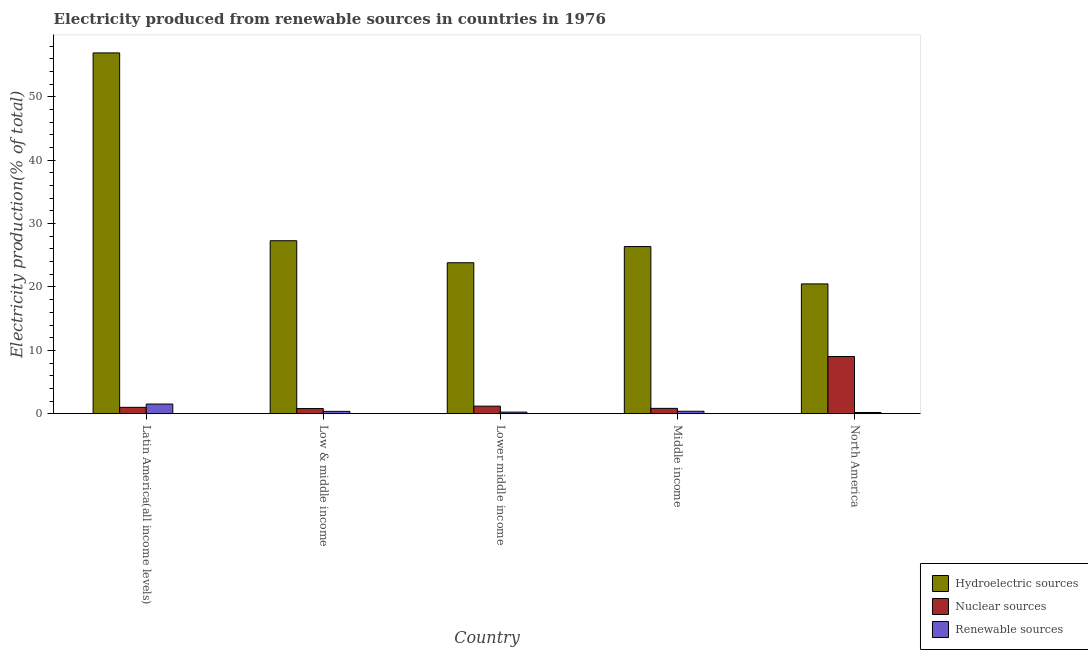How many groups of bars are there?
Keep it short and to the point. 5. Are the number of bars per tick equal to the number of legend labels?
Offer a terse response. Yes. How many bars are there on the 5th tick from the left?
Offer a very short reply. 3. How many bars are there on the 3rd tick from the right?
Your answer should be compact. 3. What is the percentage of electricity produced by hydroelectric sources in North America?
Offer a terse response. 20.48. Across all countries, what is the maximum percentage of electricity produced by hydroelectric sources?
Your answer should be compact. 56.93. Across all countries, what is the minimum percentage of electricity produced by nuclear sources?
Your answer should be compact. 0.81. In which country was the percentage of electricity produced by hydroelectric sources maximum?
Make the answer very short. Latin America(all income levels). In which country was the percentage of electricity produced by renewable sources minimum?
Make the answer very short. North America. What is the total percentage of electricity produced by hydroelectric sources in the graph?
Provide a short and direct response. 154.91. What is the difference between the percentage of electricity produced by renewable sources in Low & middle income and that in Middle income?
Your answer should be very brief. -0.01. What is the difference between the percentage of electricity produced by nuclear sources in Middle income and the percentage of electricity produced by renewable sources in North America?
Ensure brevity in your answer.  0.65. What is the average percentage of electricity produced by hydroelectric sources per country?
Your answer should be very brief. 30.98. What is the difference between the percentage of electricity produced by renewable sources and percentage of electricity produced by hydroelectric sources in Low & middle income?
Your answer should be very brief. -26.92. In how many countries, is the percentage of electricity produced by nuclear sources greater than 44 %?
Make the answer very short. 0. What is the ratio of the percentage of electricity produced by nuclear sources in Low & middle income to that in Lower middle income?
Your answer should be very brief. 0.68. What is the difference between the highest and the second highest percentage of electricity produced by hydroelectric sources?
Make the answer very short. 29.63. What is the difference between the highest and the lowest percentage of electricity produced by renewable sources?
Provide a short and direct response. 1.33. Is the sum of the percentage of electricity produced by nuclear sources in Latin America(all income levels) and Middle income greater than the maximum percentage of electricity produced by renewable sources across all countries?
Provide a succinct answer. Yes. What does the 2nd bar from the left in Low & middle income represents?
Your answer should be compact. Nuclear sources. What does the 2nd bar from the right in Middle income represents?
Give a very brief answer. Nuclear sources. Are all the bars in the graph horizontal?
Your answer should be very brief. No. Does the graph contain any zero values?
Make the answer very short. No. How are the legend labels stacked?
Provide a succinct answer. Vertical. What is the title of the graph?
Offer a very short reply. Electricity produced from renewable sources in countries in 1976. What is the Electricity production(% of total) in Hydroelectric sources in Latin America(all income levels)?
Provide a succinct answer. 56.93. What is the Electricity production(% of total) in Nuclear sources in Latin America(all income levels)?
Ensure brevity in your answer.  1.01. What is the Electricity production(% of total) of Renewable sources in Latin America(all income levels)?
Keep it short and to the point. 1.53. What is the Electricity production(% of total) in Hydroelectric sources in Low & middle income?
Keep it short and to the point. 27.3. What is the Electricity production(% of total) in Nuclear sources in Low & middle income?
Your response must be concise. 0.81. What is the Electricity production(% of total) of Renewable sources in Low & middle income?
Provide a succinct answer. 0.38. What is the Electricity production(% of total) in Hydroelectric sources in Lower middle income?
Your response must be concise. 23.83. What is the Electricity production(% of total) in Nuclear sources in Lower middle income?
Your answer should be compact. 1.2. What is the Electricity production(% of total) of Renewable sources in Lower middle income?
Your answer should be very brief. 0.25. What is the Electricity production(% of total) in Hydroelectric sources in Middle income?
Ensure brevity in your answer.  26.38. What is the Electricity production(% of total) of Nuclear sources in Middle income?
Offer a very short reply. 0.85. What is the Electricity production(% of total) of Renewable sources in Middle income?
Make the answer very short. 0.39. What is the Electricity production(% of total) of Hydroelectric sources in North America?
Keep it short and to the point. 20.48. What is the Electricity production(% of total) in Nuclear sources in North America?
Provide a short and direct response. 9.03. What is the Electricity production(% of total) of Renewable sources in North America?
Your answer should be compact. 0.2. Across all countries, what is the maximum Electricity production(% of total) of Hydroelectric sources?
Provide a succinct answer. 56.93. Across all countries, what is the maximum Electricity production(% of total) of Nuclear sources?
Offer a very short reply. 9.03. Across all countries, what is the maximum Electricity production(% of total) in Renewable sources?
Your answer should be compact. 1.53. Across all countries, what is the minimum Electricity production(% of total) of Hydroelectric sources?
Your answer should be compact. 20.48. Across all countries, what is the minimum Electricity production(% of total) of Nuclear sources?
Offer a terse response. 0.81. Across all countries, what is the minimum Electricity production(% of total) of Renewable sources?
Provide a short and direct response. 0.2. What is the total Electricity production(% of total) in Hydroelectric sources in the graph?
Offer a terse response. 154.91. What is the total Electricity production(% of total) in Nuclear sources in the graph?
Your answer should be compact. 12.9. What is the total Electricity production(% of total) in Renewable sources in the graph?
Offer a terse response. 2.75. What is the difference between the Electricity production(% of total) of Hydroelectric sources in Latin America(all income levels) and that in Low & middle income?
Provide a succinct answer. 29.63. What is the difference between the Electricity production(% of total) in Nuclear sources in Latin America(all income levels) and that in Low & middle income?
Your response must be concise. 0.2. What is the difference between the Electricity production(% of total) of Renewable sources in Latin America(all income levels) and that in Low & middle income?
Give a very brief answer. 1.16. What is the difference between the Electricity production(% of total) of Hydroelectric sources in Latin America(all income levels) and that in Lower middle income?
Provide a succinct answer. 33.1. What is the difference between the Electricity production(% of total) in Nuclear sources in Latin America(all income levels) and that in Lower middle income?
Offer a terse response. -0.19. What is the difference between the Electricity production(% of total) of Renewable sources in Latin America(all income levels) and that in Lower middle income?
Keep it short and to the point. 1.28. What is the difference between the Electricity production(% of total) in Hydroelectric sources in Latin America(all income levels) and that in Middle income?
Make the answer very short. 30.55. What is the difference between the Electricity production(% of total) of Nuclear sources in Latin America(all income levels) and that in Middle income?
Make the answer very short. 0.16. What is the difference between the Electricity production(% of total) of Renewable sources in Latin America(all income levels) and that in Middle income?
Provide a succinct answer. 1.14. What is the difference between the Electricity production(% of total) in Hydroelectric sources in Latin America(all income levels) and that in North America?
Provide a short and direct response. 36.44. What is the difference between the Electricity production(% of total) in Nuclear sources in Latin America(all income levels) and that in North America?
Your answer should be very brief. -8.02. What is the difference between the Electricity production(% of total) in Renewable sources in Latin America(all income levels) and that in North America?
Provide a short and direct response. 1.33. What is the difference between the Electricity production(% of total) of Hydroelectric sources in Low & middle income and that in Lower middle income?
Ensure brevity in your answer.  3.47. What is the difference between the Electricity production(% of total) of Nuclear sources in Low & middle income and that in Lower middle income?
Make the answer very short. -0.39. What is the difference between the Electricity production(% of total) in Renewable sources in Low & middle income and that in Lower middle income?
Provide a short and direct response. 0.12. What is the difference between the Electricity production(% of total) in Hydroelectric sources in Low & middle income and that in Middle income?
Give a very brief answer. 0.92. What is the difference between the Electricity production(% of total) in Nuclear sources in Low & middle income and that in Middle income?
Provide a succinct answer. -0.03. What is the difference between the Electricity production(% of total) in Renewable sources in Low & middle income and that in Middle income?
Your response must be concise. -0.01. What is the difference between the Electricity production(% of total) of Hydroelectric sources in Low & middle income and that in North America?
Provide a succinct answer. 6.81. What is the difference between the Electricity production(% of total) in Nuclear sources in Low & middle income and that in North America?
Keep it short and to the point. -8.21. What is the difference between the Electricity production(% of total) in Renewable sources in Low & middle income and that in North America?
Make the answer very short. 0.18. What is the difference between the Electricity production(% of total) of Hydroelectric sources in Lower middle income and that in Middle income?
Your answer should be compact. -2.55. What is the difference between the Electricity production(% of total) in Nuclear sources in Lower middle income and that in Middle income?
Offer a terse response. 0.35. What is the difference between the Electricity production(% of total) of Renewable sources in Lower middle income and that in Middle income?
Make the answer very short. -0.14. What is the difference between the Electricity production(% of total) in Hydroelectric sources in Lower middle income and that in North America?
Your answer should be compact. 3.34. What is the difference between the Electricity production(% of total) in Nuclear sources in Lower middle income and that in North America?
Ensure brevity in your answer.  -7.83. What is the difference between the Electricity production(% of total) in Renewable sources in Lower middle income and that in North America?
Keep it short and to the point. 0.06. What is the difference between the Electricity production(% of total) in Hydroelectric sources in Middle income and that in North America?
Your response must be concise. 5.89. What is the difference between the Electricity production(% of total) in Nuclear sources in Middle income and that in North America?
Provide a succinct answer. -8.18. What is the difference between the Electricity production(% of total) of Renewable sources in Middle income and that in North America?
Your answer should be very brief. 0.19. What is the difference between the Electricity production(% of total) in Hydroelectric sources in Latin America(all income levels) and the Electricity production(% of total) in Nuclear sources in Low & middle income?
Your response must be concise. 56.11. What is the difference between the Electricity production(% of total) in Hydroelectric sources in Latin America(all income levels) and the Electricity production(% of total) in Renewable sources in Low & middle income?
Offer a very short reply. 56.55. What is the difference between the Electricity production(% of total) in Nuclear sources in Latin America(all income levels) and the Electricity production(% of total) in Renewable sources in Low & middle income?
Provide a succinct answer. 0.64. What is the difference between the Electricity production(% of total) in Hydroelectric sources in Latin America(all income levels) and the Electricity production(% of total) in Nuclear sources in Lower middle income?
Your answer should be compact. 55.73. What is the difference between the Electricity production(% of total) in Hydroelectric sources in Latin America(all income levels) and the Electricity production(% of total) in Renewable sources in Lower middle income?
Your answer should be compact. 56.68. What is the difference between the Electricity production(% of total) in Nuclear sources in Latin America(all income levels) and the Electricity production(% of total) in Renewable sources in Lower middle income?
Offer a terse response. 0.76. What is the difference between the Electricity production(% of total) in Hydroelectric sources in Latin America(all income levels) and the Electricity production(% of total) in Nuclear sources in Middle income?
Your response must be concise. 56.08. What is the difference between the Electricity production(% of total) of Hydroelectric sources in Latin America(all income levels) and the Electricity production(% of total) of Renewable sources in Middle income?
Make the answer very short. 56.54. What is the difference between the Electricity production(% of total) of Nuclear sources in Latin America(all income levels) and the Electricity production(% of total) of Renewable sources in Middle income?
Ensure brevity in your answer.  0.62. What is the difference between the Electricity production(% of total) of Hydroelectric sources in Latin America(all income levels) and the Electricity production(% of total) of Nuclear sources in North America?
Provide a short and direct response. 47.9. What is the difference between the Electricity production(% of total) in Hydroelectric sources in Latin America(all income levels) and the Electricity production(% of total) in Renewable sources in North America?
Ensure brevity in your answer.  56.73. What is the difference between the Electricity production(% of total) in Nuclear sources in Latin America(all income levels) and the Electricity production(% of total) in Renewable sources in North America?
Provide a succinct answer. 0.81. What is the difference between the Electricity production(% of total) of Hydroelectric sources in Low & middle income and the Electricity production(% of total) of Nuclear sources in Lower middle income?
Give a very brief answer. 26.1. What is the difference between the Electricity production(% of total) of Hydroelectric sources in Low & middle income and the Electricity production(% of total) of Renewable sources in Lower middle income?
Offer a terse response. 27.04. What is the difference between the Electricity production(% of total) of Nuclear sources in Low & middle income and the Electricity production(% of total) of Renewable sources in Lower middle income?
Offer a very short reply. 0.56. What is the difference between the Electricity production(% of total) of Hydroelectric sources in Low & middle income and the Electricity production(% of total) of Nuclear sources in Middle income?
Give a very brief answer. 26.45. What is the difference between the Electricity production(% of total) of Hydroelectric sources in Low & middle income and the Electricity production(% of total) of Renewable sources in Middle income?
Make the answer very short. 26.91. What is the difference between the Electricity production(% of total) in Nuclear sources in Low & middle income and the Electricity production(% of total) in Renewable sources in Middle income?
Provide a short and direct response. 0.42. What is the difference between the Electricity production(% of total) of Hydroelectric sources in Low & middle income and the Electricity production(% of total) of Nuclear sources in North America?
Your response must be concise. 18.27. What is the difference between the Electricity production(% of total) in Hydroelectric sources in Low & middle income and the Electricity production(% of total) in Renewable sources in North America?
Provide a short and direct response. 27.1. What is the difference between the Electricity production(% of total) in Nuclear sources in Low & middle income and the Electricity production(% of total) in Renewable sources in North America?
Offer a terse response. 0.62. What is the difference between the Electricity production(% of total) of Hydroelectric sources in Lower middle income and the Electricity production(% of total) of Nuclear sources in Middle income?
Ensure brevity in your answer.  22.98. What is the difference between the Electricity production(% of total) of Hydroelectric sources in Lower middle income and the Electricity production(% of total) of Renewable sources in Middle income?
Offer a terse response. 23.44. What is the difference between the Electricity production(% of total) in Nuclear sources in Lower middle income and the Electricity production(% of total) in Renewable sources in Middle income?
Make the answer very short. 0.81. What is the difference between the Electricity production(% of total) in Hydroelectric sources in Lower middle income and the Electricity production(% of total) in Nuclear sources in North America?
Make the answer very short. 14.8. What is the difference between the Electricity production(% of total) of Hydroelectric sources in Lower middle income and the Electricity production(% of total) of Renewable sources in North America?
Give a very brief answer. 23.63. What is the difference between the Electricity production(% of total) in Nuclear sources in Lower middle income and the Electricity production(% of total) in Renewable sources in North America?
Provide a short and direct response. 1. What is the difference between the Electricity production(% of total) in Hydroelectric sources in Middle income and the Electricity production(% of total) in Nuclear sources in North America?
Provide a succinct answer. 17.35. What is the difference between the Electricity production(% of total) of Hydroelectric sources in Middle income and the Electricity production(% of total) of Renewable sources in North America?
Offer a very short reply. 26.18. What is the difference between the Electricity production(% of total) of Nuclear sources in Middle income and the Electricity production(% of total) of Renewable sources in North America?
Ensure brevity in your answer.  0.65. What is the average Electricity production(% of total) of Hydroelectric sources per country?
Your answer should be compact. 30.98. What is the average Electricity production(% of total) in Nuclear sources per country?
Your answer should be very brief. 2.58. What is the average Electricity production(% of total) of Renewable sources per country?
Provide a short and direct response. 0.55. What is the difference between the Electricity production(% of total) in Hydroelectric sources and Electricity production(% of total) in Nuclear sources in Latin America(all income levels)?
Offer a terse response. 55.92. What is the difference between the Electricity production(% of total) of Hydroelectric sources and Electricity production(% of total) of Renewable sources in Latin America(all income levels)?
Your answer should be compact. 55.4. What is the difference between the Electricity production(% of total) of Nuclear sources and Electricity production(% of total) of Renewable sources in Latin America(all income levels)?
Ensure brevity in your answer.  -0.52. What is the difference between the Electricity production(% of total) in Hydroelectric sources and Electricity production(% of total) in Nuclear sources in Low & middle income?
Provide a succinct answer. 26.48. What is the difference between the Electricity production(% of total) in Hydroelectric sources and Electricity production(% of total) in Renewable sources in Low & middle income?
Provide a short and direct response. 26.92. What is the difference between the Electricity production(% of total) in Nuclear sources and Electricity production(% of total) in Renewable sources in Low & middle income?
Offer a terse response. 0.44. What is the difference between the Electricity production(% of total) of Hydroelectric sources and Electricity production(% of total) of Nuclear sources in Lower middle income?
Keep it short and to the point. 22.63. What is the difference between the Electricity production(% of total) in Hydroelectric sources and Electricity production(% of total) in Renewable sources in Lower middle income?
Your answer should be very brief. 23.57. What is the difference between the Electricity production(% of total) of Nuclear sources and Electricity production(% of total) of Renewable sources in Lower middle income?
Your response must be concise. 0.95. What is the difference between the Electricity production(% of total) of Hydroelectric sources and Electricity production(% of total) of Nuclear sources in Middle income?
Offer a terse response. 25.53. What is the difference between the Electricity production(% of total) in Hydroelectric sources and Electricity production(% of total) in Renewable sources in Middle income?
Your answer should be very brief. 25.99. What is the difference between the Electricity production(% of total) in Nuclear sources and Electricity production(% of total) in Renewable sources in Middle income?
Provide a succinct answer. 0.46. What is the difference between the Electricity production(% of total) of Hydroelectric sources and Electricity production(% of total) of Nuclear sources in North America?
Your response must be concise. 11.46. What is the difference between the Electricity production(% of total) in Hydroelectric sources and Electricity production(% of total) in Renewable sources in North America?
Your response must be concise. 20.29. What is the difference between the Electricity production(% of total) of Nuclear sources and Electricity production(% of total) of Renewable sources in North America?
Offer a very short reply. 8.83. What is the ratio of the Electricity production(% of total) of Hydroelectric sources in Latin America(all income levels) to that in Low & middle income?
Your answer should be very brief. 2.09. What is the ratio of the Electricity production(% of total) of Nuclear sources in Latin America(all income levels) to that in Low & middle income?
Your answer should be compact. 1.24. What is the ratio of the Electricity production(% of total) of Renewable sources in Latin America(all income levels) to that in Low & middle income?
Offer a terse response. 4.08. What is the ratio of the Electricity production(% of total) of Hydroelectric sources in Latin America(all income levels) to that in Lower middle income?
Make the answer very short. 2.39. What is the ratio of the Electricity production(% of total) in Nuclear sources in Latin America(all income levels) to that in Lower middle income?
Offer a very short reply. 0.84. What is the ratio of the Electricity production(% of total) in Renewable sources in Latin America(all income levels) to that in Lower middle income?
Your answer should be compact. 6.06. What is the ratio of the Electricity production(% of total) of Hydroelectric sources in Latin America(all income levels) to that in Middle income?
Your answer should be compact. 2.16. What is the ratio of the Electricity production(% of total) of Nuclear sources in Latin America(all income levels) to that in Middle income?
Your answer should be very brief. 1.19. What is the ratio of the Electricity production(% of total) in Renewable sources in Latin America(all income levels) to that in Middle income?
Provide a short and direct response. 3.92. What is the ratio of the Electricity production(% of total) in Hydroelectric sources in Latin America(all income levels) to that in North America?
Ensure brevity in your answer.  2.78. What is the ratio of the Electricity production(% of total) in Nuclear sources in Latin America(all income levels) to that in North America?
Your answer should be compact. 0.11. What is the ratio of the Electricity production(% of total) in Renewable sources in Latin America(all income levels) to that in North America?
Your response must be concise. 7.77. What is the ratio of the Electricity production(% of total) of Hydroelectric sources in Low & middle income to that in Lower middle income?
Your answer should be compact. 1.15. What is the ratio of the Electricity production(% of total) in Nuclear sources in Low & middle income to that in Lower middle income?
Provide a succinct answer. 0.68. What is the ratio of the Electricity production(% of total) of Renewable sources in Low & middle income to that in Lower middle income?
Your answer should be very brief. 1.49. What is the ratio of the Electricity production(% of total) of Hydroelectric sources in Low & middle income to that in Middle income?
Your response must be concise. 1.03. What is the ratio of the Electricity production(% of total) of Nuclear sources in Low & middle income to that in Middle income?
Offer a terse response. 0.96. What is the ratio of the Electricity production(% of total) of Renewable sources in Low & middle income to that in Middle income?
Offer a very short reply. 0.96. What is the ratio of the Electricity production(% of total) in Hydroelectric sources in Low & middle income to that in North America?
Keep it short and to the point. 1.33. What is the ratio of the Electricity production(% of total) in Nuclear sources in Low & middle income to that in North America?
Offer a very short reply. 0.09. What is the ratio of the Electricity production(% of total) of Renewable sources in Low & middle income to that in North America?
Offer a very short reply. 1.91. What is the ratio of the Electricity production(% of total) of Hydroelectric sources in Lower middle income to that in Middle income?
Give a very brief answer. 0.9. What is the ratio of the Electricity production(% of total) in Nuclear sources in Lower middle income to that in Middle income?
Provide a succinct answer. 1.41. What is the ratio of the Electricity production(% of total) of Renewable sources in Lower middle income to that in Middle income?
Give a very brief answer. 0.65. What is the ratio of the Electricity production(% of total) of Hydroelectric sources in Lower middle income to that in North America?
Offer a very short reply. 1.16. What is the ratio of the Electricity production(% of total) of Nuclear sources in Lower middle income to that in North America?
Your response must be concise. 0.13. What is the ratio of the Electricity production(% of total) of Renewable sources in Lower middle income to that in North America?
Your answer should be very brief. 1.28. What is the ratio of the Electricity production(% of total) in Hydroelectric sources in Middle income to that in North America?
Your answer should be compact. 1.29. What is the ratio of the Electricity production(% of total) in Nuclear sources in Middle income to that in North America?
Ensure brevity in your answer.  0.09. What is the ratio of the Electricity production(% of total) in Renewable sources in Middle income to that in North America?
Ensure brevity in your answer.  1.98. What is the difference between the highest and the second highest Electricity production(% of total) in Hydroelectric sources?
Offer a very short reply. 29.63. What is the difference between the highest and the second highest Electricity production(% of total) in Nuclear sources?
Offer a very short reply. 7.83. What is the difference between the highest and the second highest Electricity production(% of total) in Renewable sources?
Provide a succinct answer. 1.14. What is the difference between the highest and the lowest Electricity production(% of total) of Hydroelectric sources?
Offer a terse response. 36.44. What is the difference between the highest and the lowest Electricity production(% of total) of Nuclear sources?
Offer a terse response. 8.21. What is the difference between the highest and the lowest Electricity production(% of total) of Renewable sources?
Your answer should be compact. 1.33. 